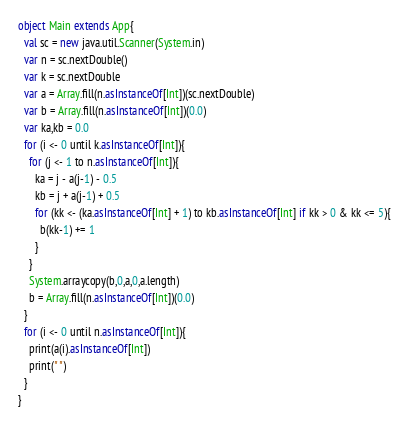<code> <loc_0><loc_0><loc_500><loc_500><_Scala_>object Main extends App{
  val sc = new java.util.Scanner(System.in)
  var n = sc.nextDouble()
  var k = sc.nextDouble
  var a = Array.fill(n.asInstanceOf[Int])(sc.nextDouble)
  var b = Array.fill(n.asInstanceOf[Int])(0.0)
  var ka,kb = 0.0
  for (i <- 0 until k.asInstanceOf[Int]){
    for (j <- 1 to n.asInstanceOf[Int]){
      ka = j - a(j-1) - 0.5
      kb = j + a(j-1) + 0.5
      for (kk <- (ka.asInstanceOf[Int] + 1) to kb.asInstanceOf[Int] if kk > 0 & kk <= 5){
        b(kk-1) += 1
      }
    }
    System.arraycopy(b,0,a,0,a.length)
    b = Array.fill(n.asInstanceOf[Int])(0.0)
  }
  for (i <- 0 until n.asInstanceOf[Int]){
    print(a(i).asInstanceOf[Int])
    print(" ")
  }
}
</code> 